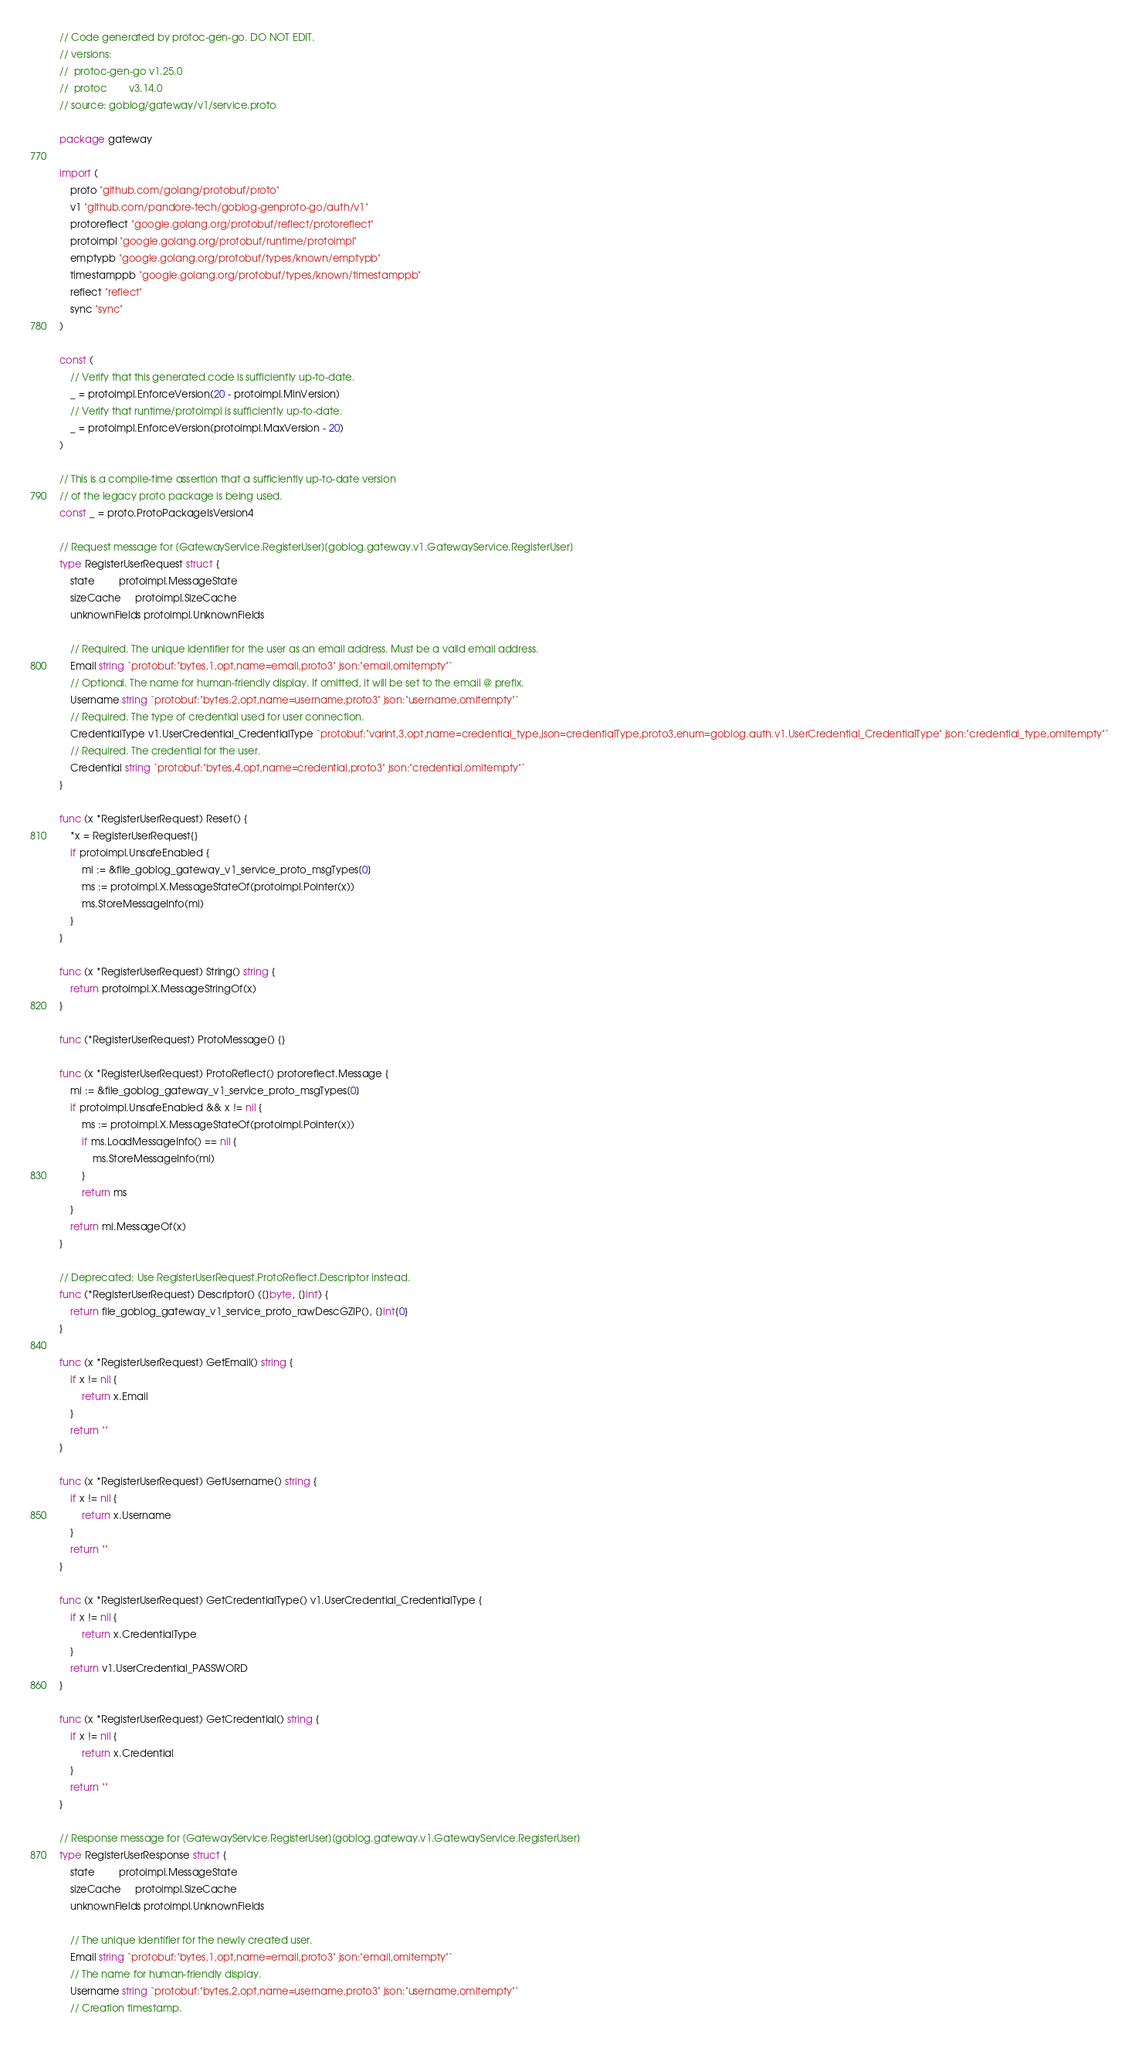<code> <loc_0><loc_0><loc_500><loc_500><_Go_>// Code generated by protoc-gen-go. DO NOT EDIT.
// versions:
// 	protoc-gen-go v1.25.0
// 	protoc        v3.14.0
// source: goblog/gateway/v1/service.proto

package gateway

import (
	proto "github.com/golang/protobuf/proto"
	v1 "github.com/pandore-tech/goblog-genproto-go/auth/v1"
	protoreflect "google.golang.org/protobuf/reflect/protoreflect"
	protoimpl "google.golang.org/protobuf/runtime/protoimpl"
	emptypb "google.golang.org/protobuf/types/known/emptypb"
	timestamppb "google.golang.org/protobuf/types/known/timestamppb"
	reflect "reflect"
	sync "sync"
)

const (
	// Verify that this generated code is sufficiently up-to-date.
	_ = protoimpl.EnforceVersion(20 - protoimpl.MinVersion)
	// Verify that runtime/protoimpl is sufficiently up-to-date.
	_ = protoimpl.EnforceVersion(protoimpl.MaxVersion - 20)
)

// This is a compile-time assertion that a sufficiently up-to-date version
// of the legacy proto package is being used.
const _ = proto.ProtoPackageIsVersion4

// Request message for [GatewayService.RegisterUser][goblog.gateway.v1.GatewayService.RegisterUser]
type RegisterUserRequest struct {
	state         protoimpl.MessageState
	sizeCache     protoimpl.SizeCache
	unknownFields protoimpl.UnknownFields

	// Required. The unique identifier for the user as an email address. Must be a valid email address.
	Email string `protobuf:"bytes,1,opt,name=email,proto3" json:"email,omitempty"`
	// Optional. The name for human-friendly display. If omitted, it will be set to the email @ prefix.
	Username string `protobuf:"bytes,2,opt,name=username,proto3" json:"username,omitempty"`
	// Required. The type of credential used for user connection.
	CredentialType v1.UserCredential_CredentialType `protobuf:"varint,3,opt,name=credential_type,json=credentialType,proto3,enum=goblog.auth.v1.UserCredential_CredentialType" json:"credential_type,omitempty"`
	// Required. The credential for the user.
	Credential string `protobuf:"bytes,4,opt,name=credential,proto3" json:"credential,omitempty"`
}

func (x *RegisterUserRequest) Reset() {
	*x = RegisterUserRequest{}
	if protoimpl.UnsafeEnabled {
		mi := &file_goblog_gateway_v1_service_proto_msgTypes[0]
		ms := protoimpl.X.MessageStateOf(protoimpl.Pointer(x))
		ms.StoreMessageInfo(mi)
	}
}

func (x *RegisterUserRequest) String() string {
	return protoimpl.X.MessageStringOf(x)
}

func (*RegisterUserRequest) ProtoMessage() {}

func (x *RegisterUserRequest) ProtoReflect() protoreflect.Message {
	mi := &file_goblog_gateway_v1_service_proto_msgTypes[0]
	if protoimpl.UnsafeEnabled && x != nil {
		ms := protoimpl.X.MessageStateOf(protoimpl.Pointer(x))
		if ms.LoadMessageInfo() == nil {
			ms.StoreMessageInfo(mi)
		}
		return ms
	}
	return mi.MessageOf(x)
}

// Deprecated: Use RegisterUserRequest.ProtoReflect.Descriptor instead.
func (*RegisterUserRequest) Descriptor() ([]byte, []int) {
	return file_goblog_gateway_v1_service_proto_rawDescGZIP(), []int{0}
}

func (x *RegisterUserRequest) GetEmail() string {
	if x != nil {
		return x.Email
	}
	return ""
}

func (x *RegisterUserRequest) GetUsername() string {
	if x != nil {
		return x.Username
	}
	return ""
}

func (x *RegisterUserRequest) GetCredentialType() v1.UserCredential_CredentialType {
	if x != nil {
		return x.CredentialType
	}
	return v1.UserCredential_PASSWORD
}

func (x *RegisterUserRequest) GetCredential() string {
	if x != nil {
		return x.Credential
	}
	return ""
}

// Response message for [GatewayService.RegisterUser][goblog.gateway.v1.GatewayService.RegisterUser]
type RegisterUserResponse struct {
	state         protoimpl.MessageState
	sizeCache     protoimpl.SizeCache
	unknownFields protoimpl.UnknownFields

	// The unique identifier for the newly created user.
	Email string `protobuf:"bytes,1,opt,name=email,proto3" json:"email,omitempty"`
	// The name for human-friendly display.
	Username string `protobuf:"bytes,2,opt,name=username,proto3" json:"username,omitempty"`
	// Creation timestamp.</code> 